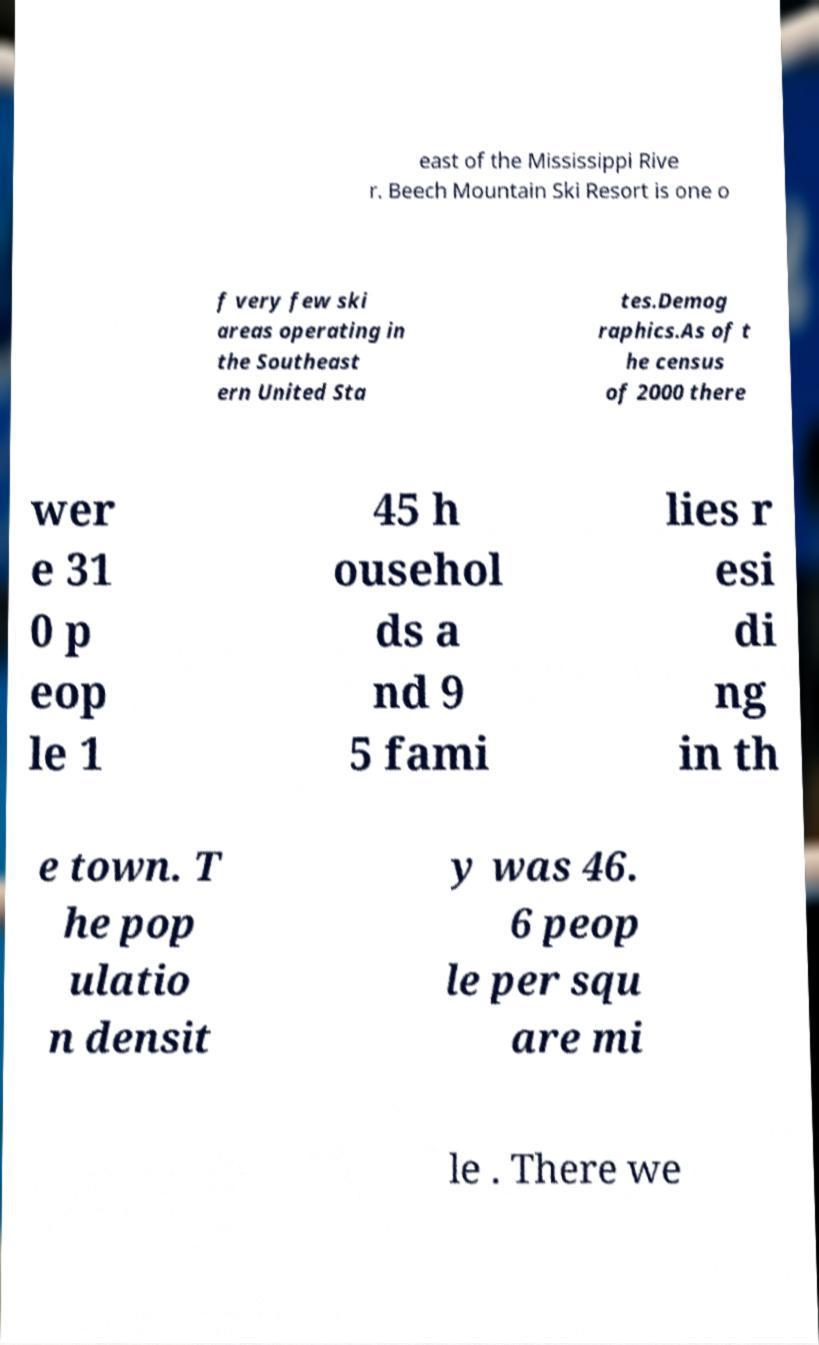Please identify and transcribe the text found in this image. east of the Mississippi Rive r. Beech Mountain Ski Resort is one o f very few ski areas operating in the Southeast ern United Sta tes.Demog raphics.As of t he census of 2000 there wer e 31 0 p eop le 1 45 h ousehol ds a nd 9 5 fami lies r esi di ng in th e town. T he pop ulatio n densit y was 46. 6 peop le per squ are mi le . There we 